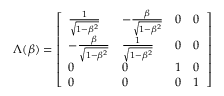<formula> <loc_0><loc_0><loc_500><loc_500>\Lambda ( \beta ) = { \left [ \begin{array} { l l l l } { { \frac { 1 } { \sqrt { 1 - \beta ^ { 2 } } } } } & { - { \frac { \beta } { \sqrt { 1 - \beta ^ { 2 } } } } } & { 0 } & { 0 } \\ { - { \frac { \beta } { \sqrt { 1 - \beta ^ { 2 } } } } } & { { \frac { 1 } { \sqrt { 1 - \beta ^ { 2 } } } } } & { 0 } & { 0 } \\ { 0 } & { 0 } & { 1 } & { 0 } \\ { 0 } & { 0 } & { 0 } & { 1 } \end{array} \right ] }</formula> 